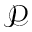<formula> <loc_0><loc_0><loc_500><loc_500>\mathcal { P }</formula> 